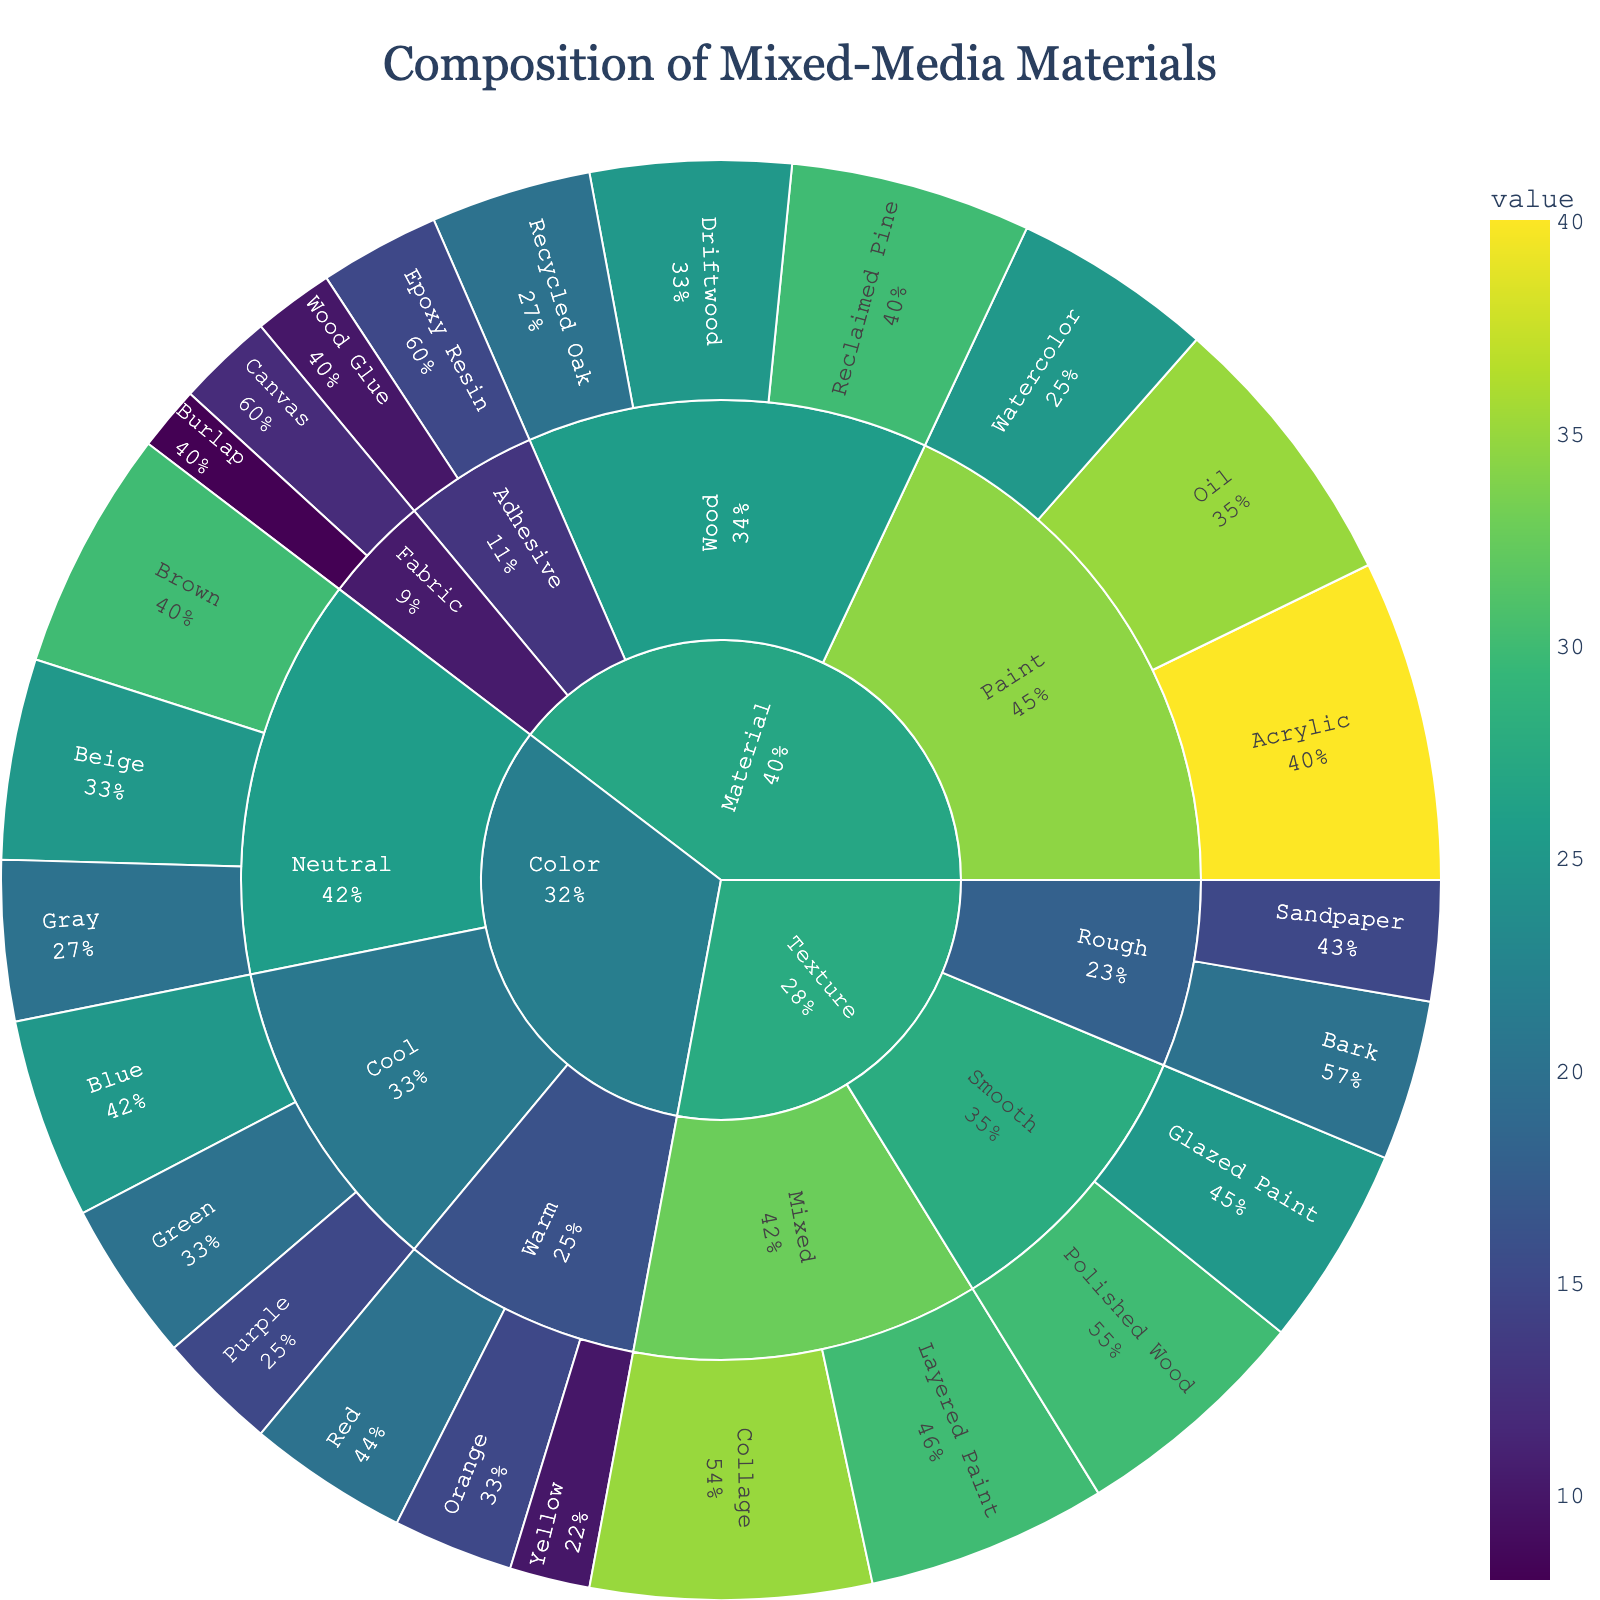What is the title of the figure? The title is displayed prominently at the top of the sunburst plot.
Answer: Composition of Mixed-Media Materials Which material type has the highest total value? Look at the segments for each material and add up their values (Wood: 30+25+20 = 75, Paint: 40+35+25 = 100, Adhesive: 15+10 = 25, Fabric: 8+12 = 20). Paint has the highest total value.
Answer: Paint What is the percentage of Reclaimed Pine within the Wood category? The value for Reclaimed Pine is 30, and the total for Wood is 75. The percentage is calculated as (30/75) * 100.
Answer: 40% How many subcategories are there under the Color category? Look for all segments directly branching from the Color category: Warm, Cool, Neutral. Count them.
Answer: 3 Which subcategory under the Texture category has the lowest total value? Compare values under Texture: Smooth (30+25), Rough (20+15), Mixed (35+30). Rough has the lowest value.
Answer: Rough What are the items listed under the Fabric subcategory? Trace all segments stemming from Fabric.
Answer: Burlap, Canvas Which item has the highest value under the Paint subcategory? Compare the values for items under Paint: Acrylic (40), Oil (35), Watercolor (25). Acrylic has the highest value.
Answer: Acrylic If you combine the values of all Wood items, how does it compare to the value of all Neutral colors? Sum Wood values: 30+25+20=75. Sum Neutral color values: 30+25+20=75. Both totals are the same.
Answer: Equal Which category has the most diverse subcategories in terms of number of unique items? Count how many unique items each subcategory has:
- Color: Warm (3), Cool (3), Neutral (3)
- Texture: Smooth (2), Rough (2), Mixed (2)
- Material: Wood (3), Paint (3), Adhesive (2), Fabric (2). 
Material has the most diverse subcategories.
Answer: Material What is the combined value of all Rough textures? Add values for Bark and Sandpaper: 20 + 15 = 35.
Answer: 35 